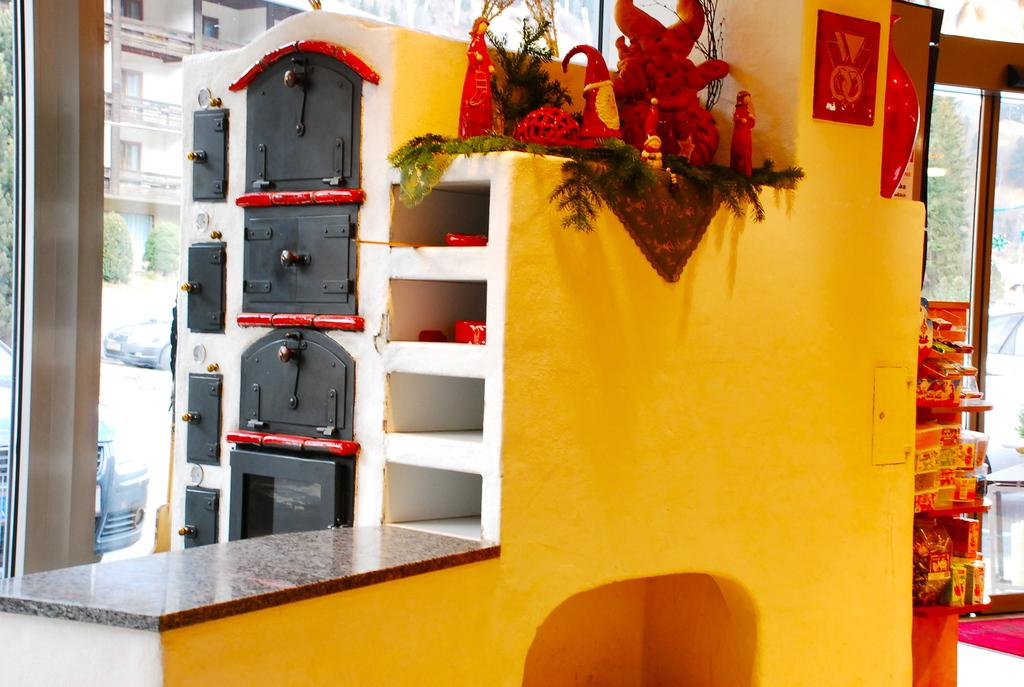What is the main object in the middle of the image? There is a toy house in the middle of the image. What type of wall is on the left side of the image? There is a glass wall on the left side of the image. What can be seen in the background of the image? There are vehicles, trees, and buildings in the background of the image. What type of canvas is used to create the toy house in the image? The toy house is not made of canvas; it is a toy made of plastic or other materials. What kind of beam supports the glass wall in the image? There is no beam supporting the glass wall in the image; it is a glass wall without any visible support. 